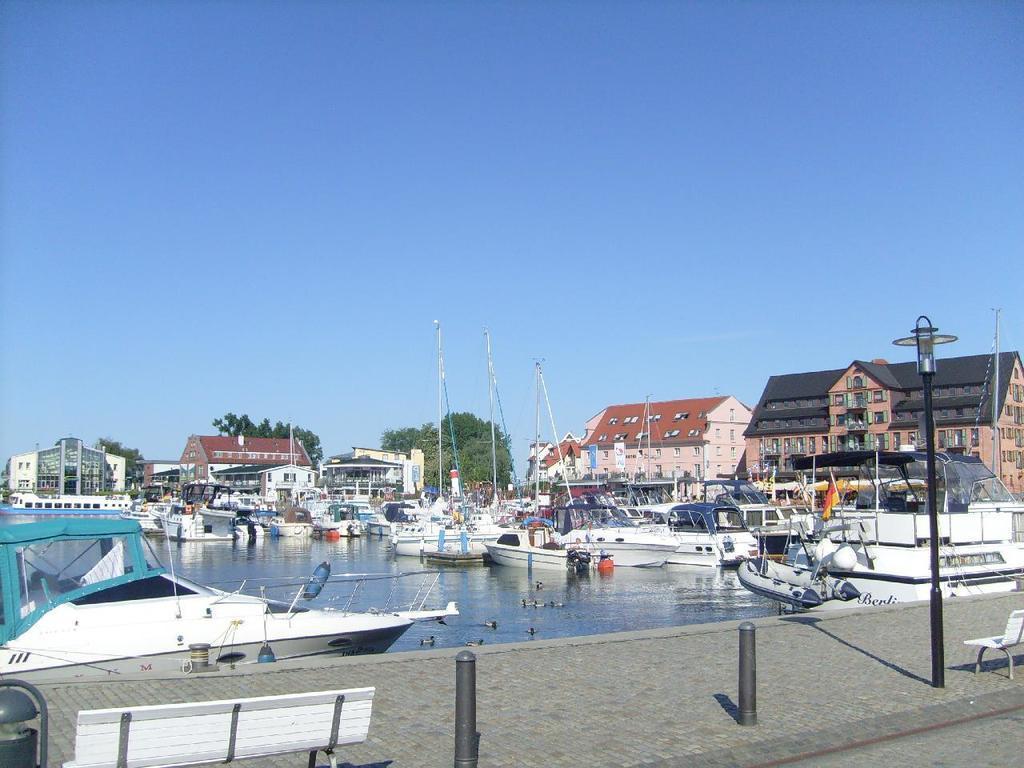How would you summarize this image in a sentence or two? In this image I can see the lake , on the lake I can see boats, in the foreground I can see a chair , pole, bench, some small poles, in the middle there are some trees, houses visible , at the top I can see the sky. 